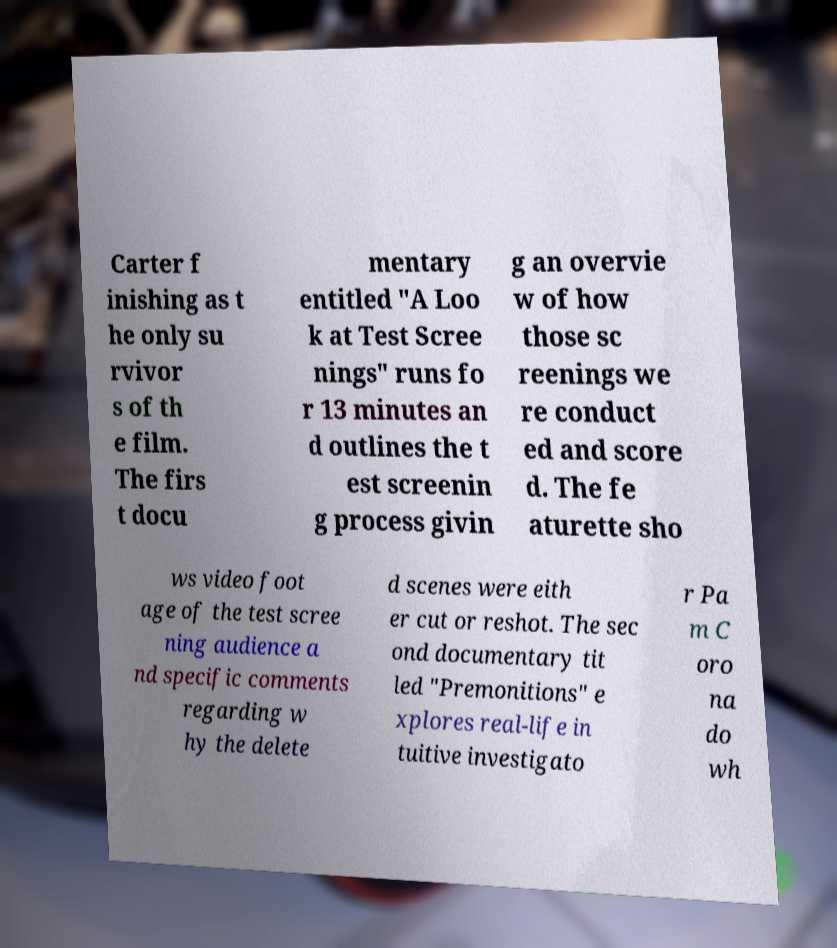Can you accurately transcribe the text from the provided image for me? Carter f inishing as t he only su rvivor s of th e film. The firs t docu mentary entitled "A Loo k at Test Scree nings" runs fo r 13 minutes an d outlines the t est screenin g process givin g an overvie w of how those sc reenings we re conduct ed and score d. The fe aturette sho ws video foot age of the test scree ning audience a nd specific comments regarding w hy the delete d scenes were eith er cut or reshot. The sec ond documentary tit led "Premonitions" e xplores real-life in tuitive investigato r Pa m C oro na do wh 